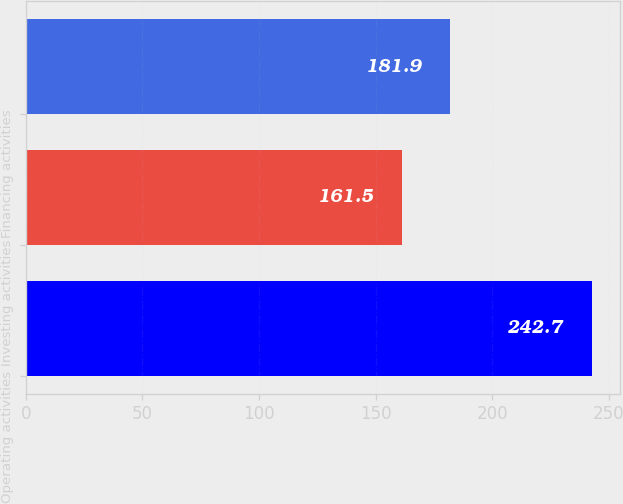<chart> <loc_0><loc_0><loc_500><loc_500><bar_chart><fcel>Operating activities<fcel>Investing activities<fcel>Financing activities<nl><fcel>242.7<fcel>161.5<fcel>181.9<nl></chart> 